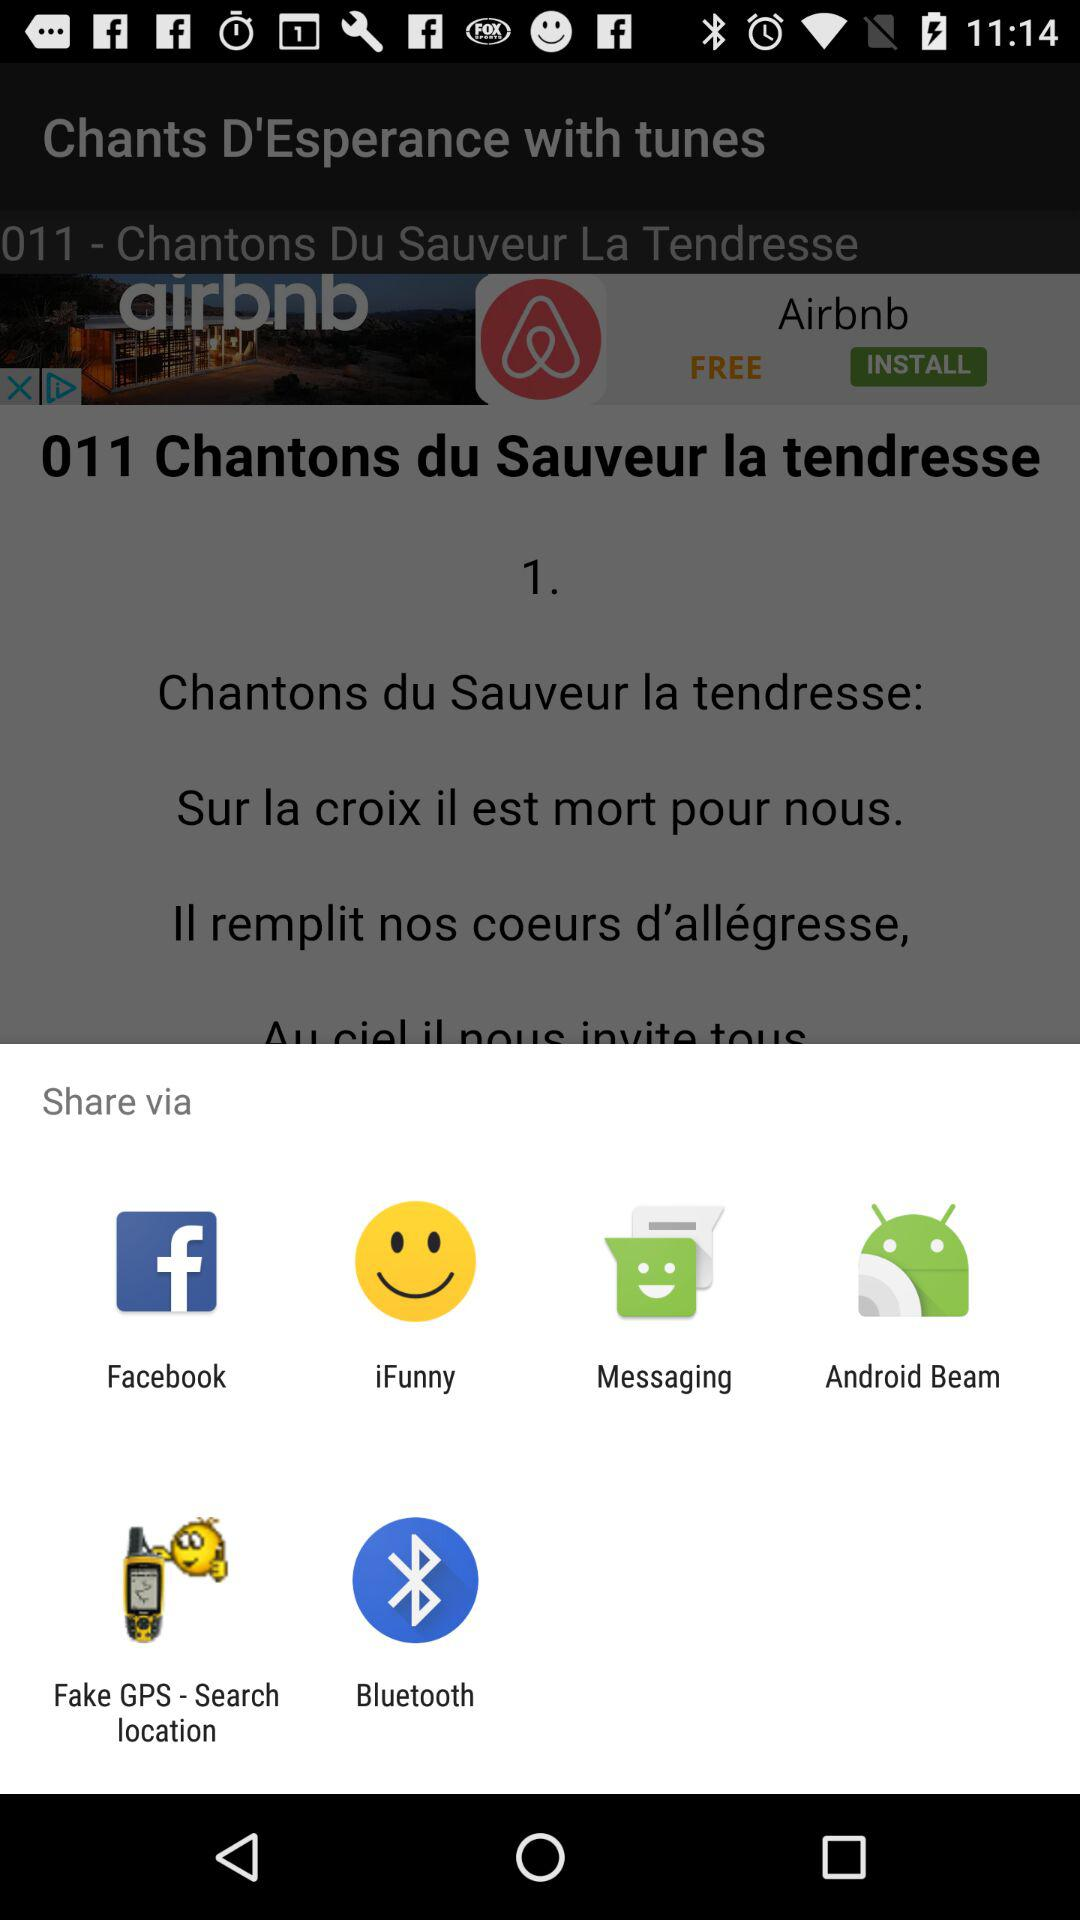Which apps can we use to share the tunes? You can use "Facebook", "iFunny", "Messaging", "Android Beam", "Fake GPS - Search location" and "Bluetooth" to share the tunes. 